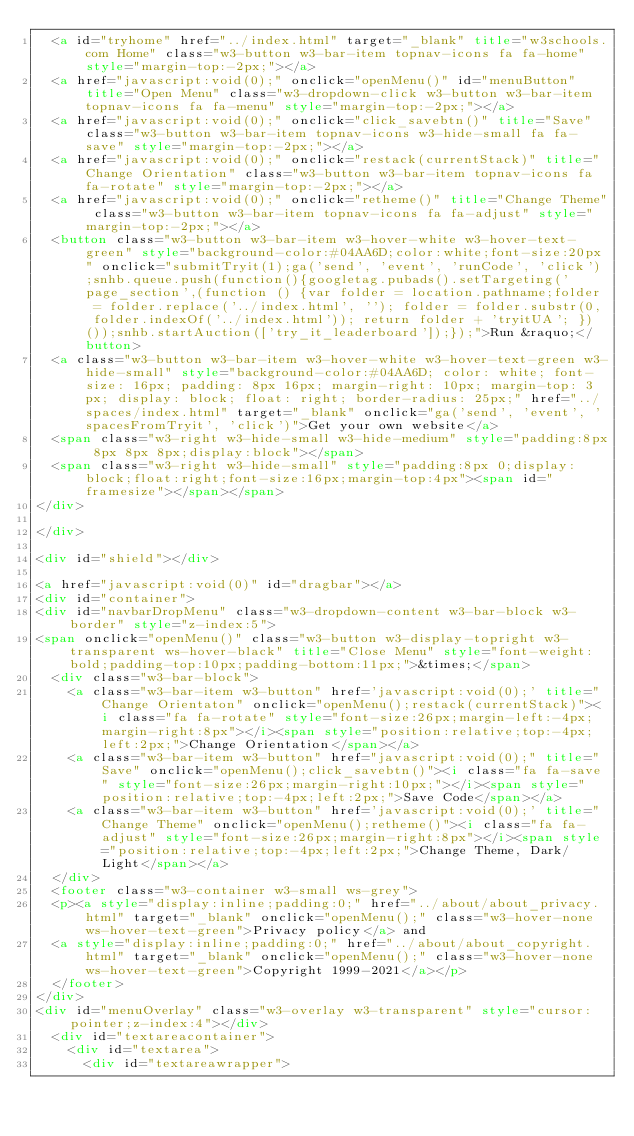Convert code to text. <code><loc_0><loc_0><loc_500><loc_500><_HTML_>  <a id="tryhome" href="../index.html" target="_blank" title="w3schools.com Home" class="w3-button w3-bar-item topnav-icons fa fa-home" style="margin-top:-2px;"></a>
  <a href="javascript:void(0);" onclick="openMenu()" id="menuButton" title="Open Menu" class="w3-dropdown-click w3-button w3-bar-item topnav-icons fa fa-menu" style="margin-top:-2px;"></a>
  <a href="javascript:void(0);" onclick="click_savebtn()" title="Save" class="w3-button w3-bar-item topnav-icons w3-hide-small fa fa-save" style="margin-top:-2px;"></a>
  <a href="javascript:void(0);" onclick="restack(currentStack)" title="Change Orientation" class="w3-button w3-bar-item topnav-icons fa fa-rotate" style="margin-top:-2px;"></a>
  <a href="javascript:void(0);" onclick="retheme()" title="Change Theme" class="w3-button w3-bar-item topnav-icons fa fa-adjust" style="margin-top:-2px;"></a>
  <button class="w3-button w3-bar-item w3-hover-white w3-hover-text-green" style="background-color:#04AA6D;color:white;font-size:20px" onclick="submitTryit(1);ga('send', 'event', 'runCode', 'click');snhb.queue.push(function(){googletag.pubads().setTargeting('page_section',(function () {var folder = location.pathname;folder = folder.replace('../index.html', ''); folder = folder.substr(0, folder.indexOf('../index.html')); return folder + 'tryitUA'; })());snhb.startAuction(['try_it_leaderboard']);});">Run &raquo;</button>
  <a class="w3-button w3-bar-item w3-hover-white w3-hover-text-green w3-hide-small" style="background-color:#04AA6D; color: white; font-size: 16px; padding: 8px 16px; margin-right: 10px; margin-top: 3px; display: block; float: right; border-radius: 25px;" href="../spaces/index.html" target="_blank" onclick="ga('send', 'event', 'spacesFromTryit', 'click')">Get your own website</a>
  <span class="w3-right w3-hide-small w3-hide-medium" style="padding:8px 8px 8px 8px;display:block"></span>
  <span class="w3-right w3-hide-small" style="padding:8px 0;display:block;float:right;font-size:16px;margin-top:4px"><span id="framesize"></span></span>
</div>

</div>

<div id="shield"></div>

<a href="javascript:void(0)" id="dragbar"></a>
<div id="container">
<div id="navbarDropMenu" class="w3-dropdown-content w3-bar-block w3-border" style="z-index:5">
<span onclick="openMenu()" class="w3-button w3-display-topright w3-transparent ws-hover-black" title="Close Menu" style="font-weight:bold;padding-top:10px;padding-bottom:11px;">&times;</span>
  <div class="w3-bar-block">
    <a class="w3-bar-item w3-button" href='javascript:void(0);' title="Change Orientaton" onclick="openMenu();restack(currentStack)"><i class="fa fa-rotate" style="font-size:26px;margin-left:-4px;margin-right:8px"></i><span style="position:relative;top:-4px;left:2px;">Change Orientation</span></a>
    <a class="w3-bar-item w3-button" href="javascript:void(0);" title="Save" onclick="openMenu();click_savebtn()"><i class="fa fa-save" style="font-size:26px;margin-right:10px;"></i><span style="position:relative;top:-4px;left:2px;">Save Code</span></a>
    <a class="w3-bar-item w3-button" href='javascript:void(0);' title="Change Theme" onclick="openMenu();retheme()"><i class="fa fa-adjust" style="font-size:26px;margin-right:8px"></i><span style="position:relative;top:-4px;left:2px;">Change Theme, Dark/Light</span></a>
  </div>
  <footer class="w3-container w3-small ws-grey">
  <p><a style="display:inline;padding:0;" href="../about/about_privacy.html" target="_blank" onclick="openMenu();" class="w3-hover-none ws-hover-text-green">Privacy policy</a> and 
  <a style="display:inline;padding:0;" href="../about/about_copyright.html" target="_blank" onclick="openMenu();" class="w3-hover-none ws-hover-text-green">Copyright 1999-2021</a></p>
  </footer>
</div>
<div id="menuOverlay" class="w3-overlay w3-transparent" style="cursor:pointer;z-index:4"></div>
  <div id="textareacontainer">
    <div id="textarea">
      <div id="textareawrapper"></code> 